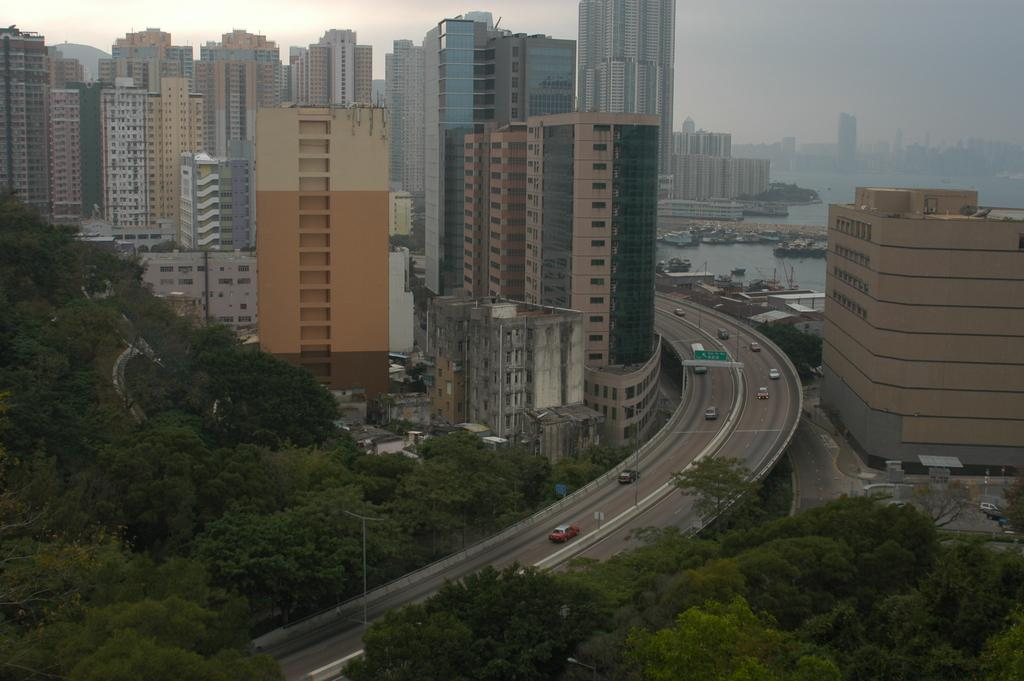What type of view is shown in the image? The image is an aerial view. What natural elements can be seen in the image? There are trees and a river in the image. What man-made structures are visible in the image? There is a bridge and buildings in the image. What is happening on the bridge in the image? Vehicles are moving on the bridge. What type of scissors can be seen cutting the flesh of the animal in the image? There are no scissors or animals present in the image; it is an aerial view of a landscape with trees, a river, a bridge, and buildings. 